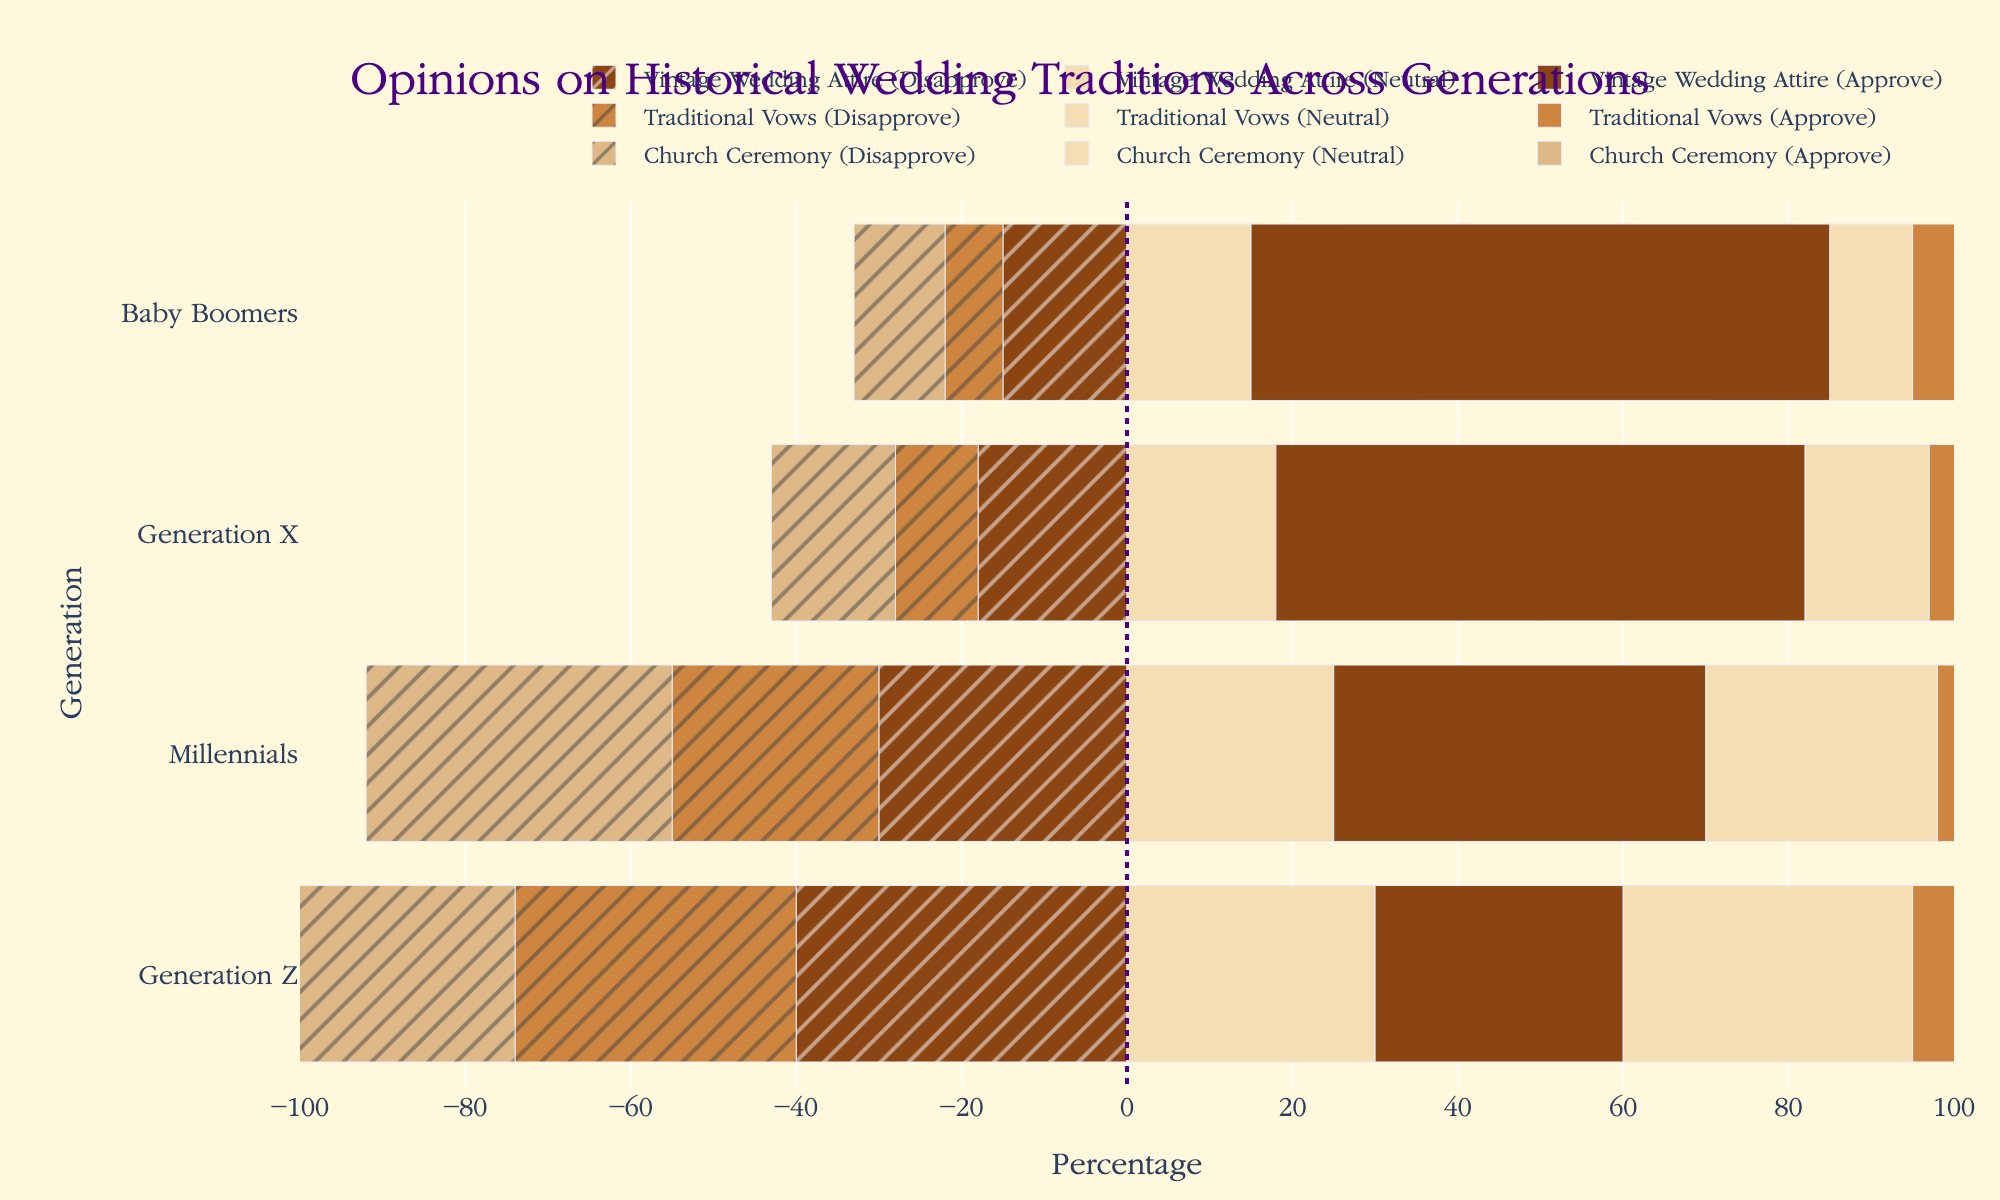What's the difference in strong approval for vintage wedding attire between Baby Boomers and Generation Z? The percentage of Strongly Approve for Baby Boomers is 30% and for Generation Z is 10%. So, the difference is 30% - 10%.
Answer: 20% Which generation has the highest neutral response for traditional vows? Checking the neutral response percentage for each generation: Baby Boomers (10%), Generation X (15%), Millennials (28%), and Generation Z (35%). Generation Z has the highest neutral response.
Answer: Generation Z Which tradition is most approved by Generation X? Adding the Approve and Strongly Approve percentages for each tradition in Generation X:
- Vintage Wedding Attire: 37% + 27% = 64%
- Traditional Vows: 33% + 42% = 75%
- Church Ceremony: 33% + 35% = 68%
Therefore, Traditional Vows have the highest approval.
Answer: Traditional Vows What is the sum of the disapproval percentages for millennial views on church ceremonies? The sum of Strongly Disapprove and Disapprove percentages for Millennials on Church Ceremony is 12% + 25%.
Answer: 37% Which generation has the smallest gap between approval and disapproval for vintage wedding attire? Checking the range for each generation by subtracting disapprove sum from approve sum:
- Baby Boomers: (40% + 30%) - (5% + 10%) = 55%
- Generation X: (37% + 27%) - (6% + 12%) = 46%
- Millennials: (30% + 15%) - (10% + 20%) = 15%
- Generation Z: (20% + 10%) - (15% + 25%) = -10%
Millennials have the smallest positive gap.
Answer: Millennials What percentage of Baby Boomers disapprove of church ceremonies? The sum of Strongly Disapprove and Disapprove percentages for Baby Boomers on Church Ceremony is 3% + 8%.
Answer: 11% Which tradition has the highest disapproval percentage among Generation Z? Summing the Strongly Disapprove and Disapprove percentages for each tradition among Generation Z:
- Vintage Wedding Attire: 15% + 25% = 40%
- Traditional Vows: 12% + 22% = 34%
- Church Ceremony: 18% + 28% = 46%
Church Ceremony has the highest disapproval.
Answer: Church Ceremony How does the neutral response for vintage wedding attire among Baby Boomers compare to that of Millennials? Baby Boomers have a neutral response percentage of 15% for Vintage Wedding Attire, while Millennials have 25%. The comparison shows that Millennials have a higher neutral response.
Answer: Millennials are higher Which tradition has the most polarized (combined strongly approve and strongly disapprove) opinion among Generation X? Summing the Strongly Approve and Strongly Disapprove percentages for each tradition among Generation X:
- Vintage Wedding Attire: 6% + 27% = 33%
- Traditional Vows: 3% + 42% = 45%
- Church Ceremony: 5% + 35% = 40%
Traditional Vows have the most polarized opinion.
Answer: Traditional Vows 